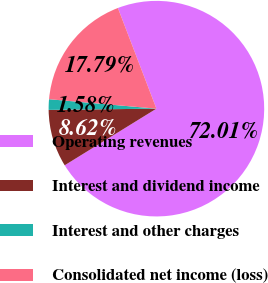Convert chart to OTSL. <chart><loc_0><loc_0><loc_500><loc_500><pie_chart><fcel>Operating revenues<fcel>Interest and dividend income<fcel>Interest and other charges<fcel>Consolidated net income (loss)<nl><fcel>72.02%<fcel>8.62%<fcel>1.58%<fcel>17.79%<nl></chart> 